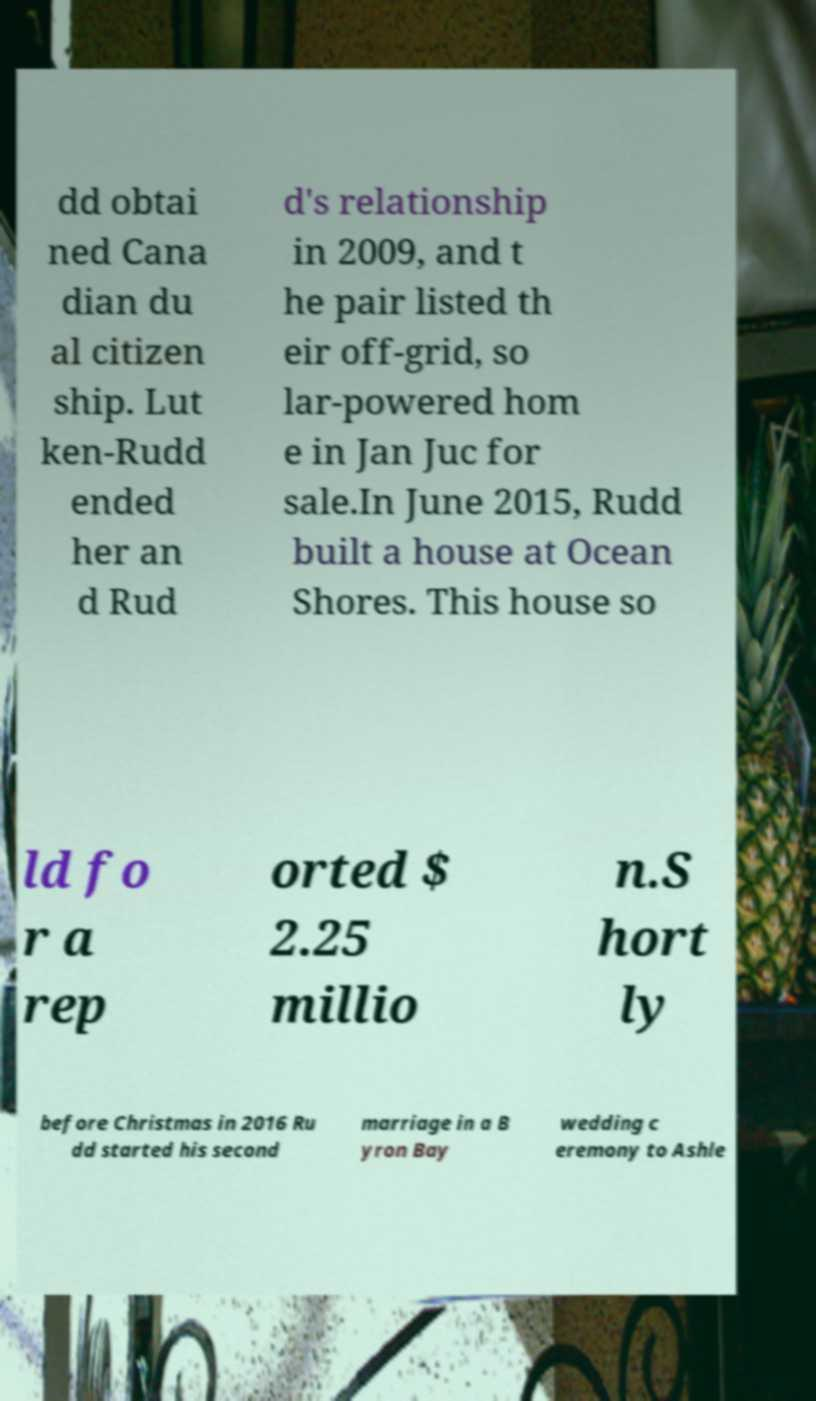For documentation purposes, I need the text within this image transcribed. Could you provide that? dd obtai ned Cana dian du al citizen ship. Lut ken-Rudd ended her an d Rud d's relationship in 2009, and t he pair listed th eir off-grid, so lar-powered hom e in Jan Juc for sale.In June 2015, Rudd built a house at Ocean Shores. This house so ld fo r a rep orted $ 2.25 millio n.S hort ly before Christmas in 2016 Ru dd started his second marriage in a B yron Bay wedding c eremony to Ashle 